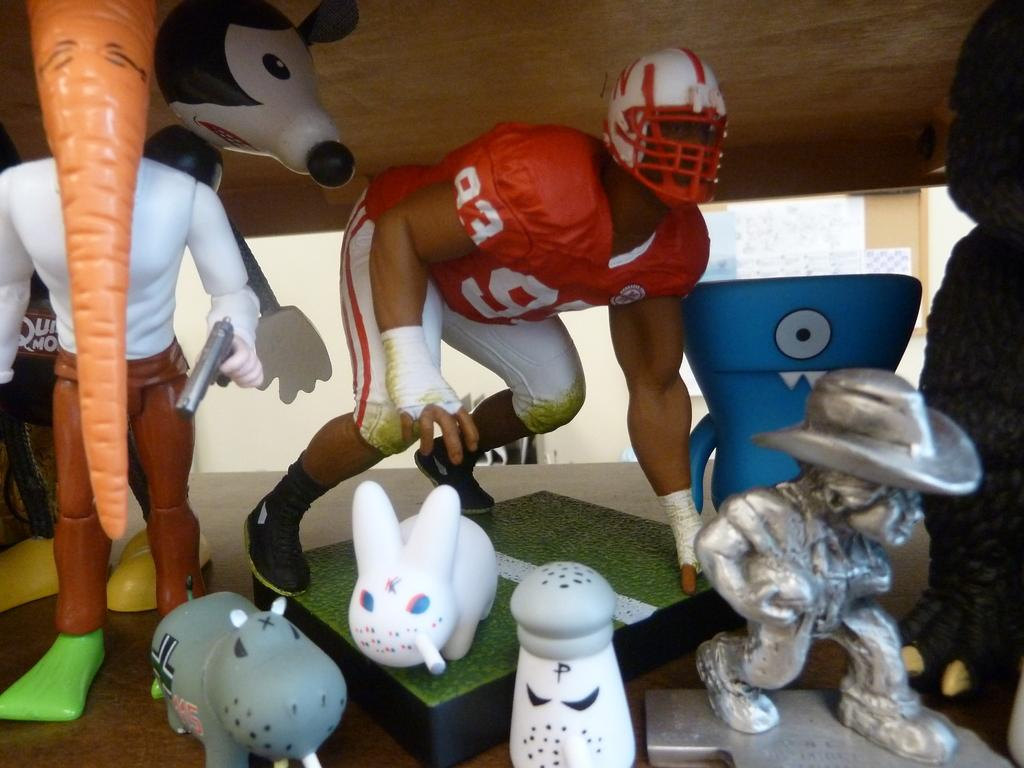Who is the main subject in the image? There is a man in the center of the image. What is the man doing in the image? The man is bending. What is the man wearing in the image? The man is wearing a helmet. What other objects can be seen in the image? There are blocks, toys, statues, and a sculpture in the image. What time of day is it in the image? The provided facts do not mention the time of day, so it cannot be determined from the image. 